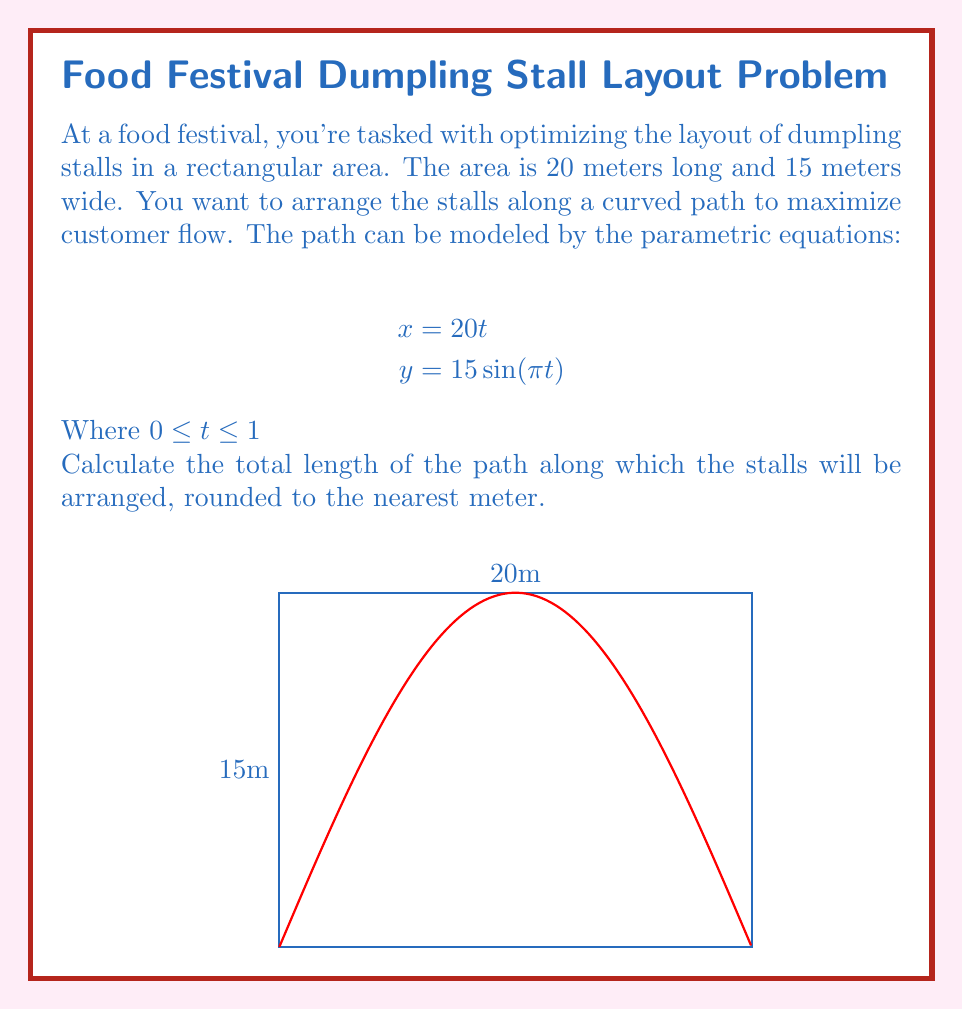Could you help me with this problem? To find the length of the path, we need to use the arc length formula for parametric equations:

$$L = \int_a^b \sqrt{\left(\frac{dx}{dt}\right)^2 + \left(\frac{dy}{dt}\right)^2} dt$$

Step 1: Find $\frac{dx}{dt}$ and $\frac{dy}{dt}$
$$\frac{dx}{dt} = 20$$
$$\frac{dy}{dt} = 15\pi \cos(\pi t)$$

Step 2: Substitute into the arc length formula
$$L = \int_0^1 \sqrt{20^2 + (15\pi \cos(\pi t))^2} dt$$

Step 3: Simplify under the square root
$$L = \int_0^1 \sqrt{400 + 225\pi^2 \cos^2(\pi t)} dt$$

Step 4: This integral cannot be solved analytically, so we need to use numerical integration. Using a computer algebra system or calculator with numerical integration capabilities, we can evaluate this integral:

$$L \approx 26.8328$$

Step 5: Round to the nearest meter
$$L \approx 27 \text{ meters}$$
Answer: 27 meters 